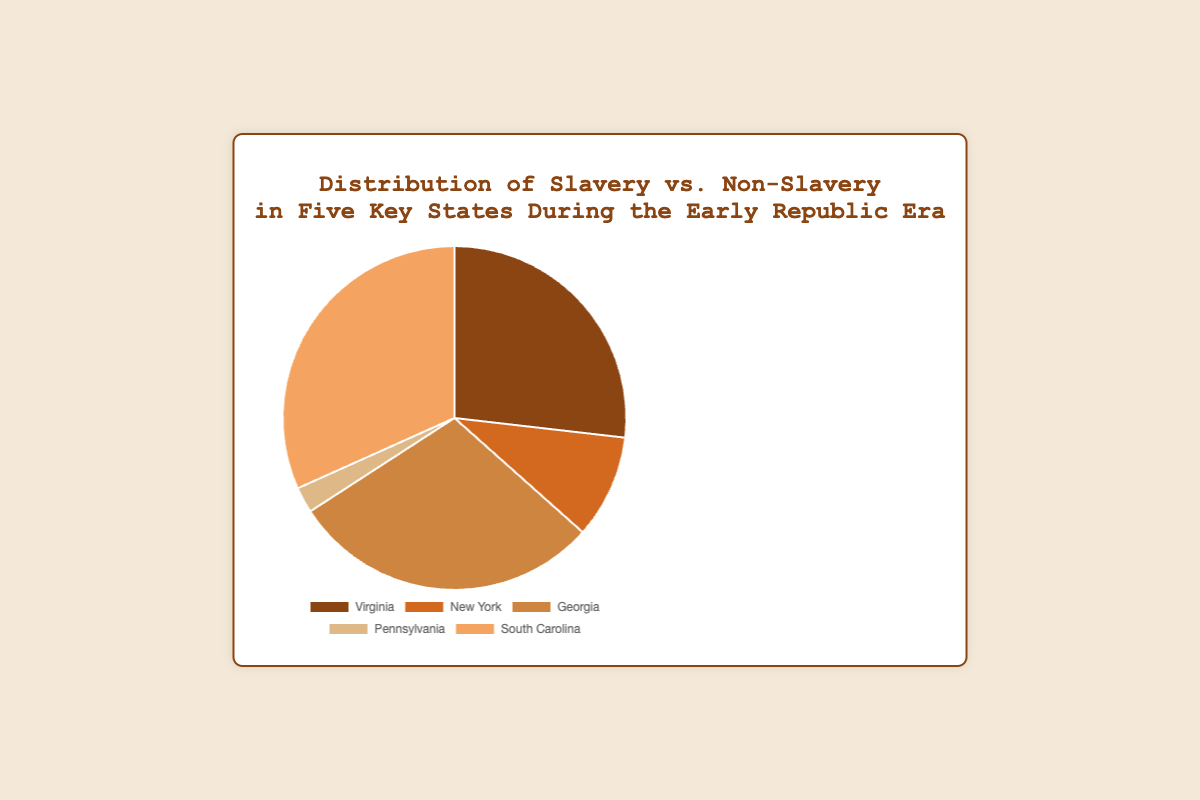Which state has the highest percentage of slavery? The figure shows the percentage of slavery in each state. The state with the highest percentage is South Carolina with 65%.
Answer: South Carolina Which state has the lowest percentage of slavery? The figure shows the percentage of slavery in each state. The state with the lowest percentage is Pennsylvania with 5%.
Answer: Pennsylvania What is the combined percentage of slavery in Virginia and Georgia? To find the combined percentage, add the slavery percentages of Virginia (55%) and Georgia (60%): 55 + 60 = 115.
Answer: 115% Which state has a higher percentage of non-slavery, New York or Pennsylvania? The figure indicates that New York has 80% non-slavery, while Pennsylvania has 95% non-slavery. Pennsylvania has the higher percentage.
Answer: Pennsylvania What is the difference in slavery percentages between South Carolina and New York? To find the difference, subtract the slavery percentage of New York (20%) from that of South Carolina (65%): 65 - 20 = 45.
Answer: 45% How much greater is the percentage of slavery in Georgia compared to Virginia? To compare, subtract the slavery percentage in Virginia (55%) from the percentage in Georgia (60%): 60 - 55 = 5.
Answer: 5% Among the states listed, which has the smallest percentage of non-slavery? The figure indicates non-slavery percentages for each state. Virginia has the smallest percentage of non-slavery with 45%.
Answer: Virginia Which color represents the state with 20% slavery in the figure? The figure shows color-coded sections for each state. The state with 20% slavery is New York, represented by the color [look at the color corresponding to New York in the chart].
Answer: brownish (exact color based on provided palette) What is the average slavery percentage across all five states? Calculate the average by summing the percentages of slavery across the five states and dividing by five: (55 + 20 + 60 + 5 + 65) / 5 = 41.
Answer: 41% Which states have a non-slavery percentage greater than 50%? States with non-slavery percentages greater than 50% can be identified directly from the figure. These states are New York (80%) and Pennsylvania (95%).
Answer: New York, Pennsylvania 